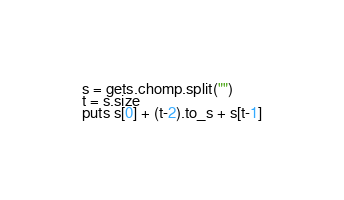Convert code to text. <code><loc_0><loc_0><loc_500><loc_500><_Ruby_>s = gets.chomp.split("")
t = s.size
puts s[0] + (t-2).to_s + s[t-1]</code> 